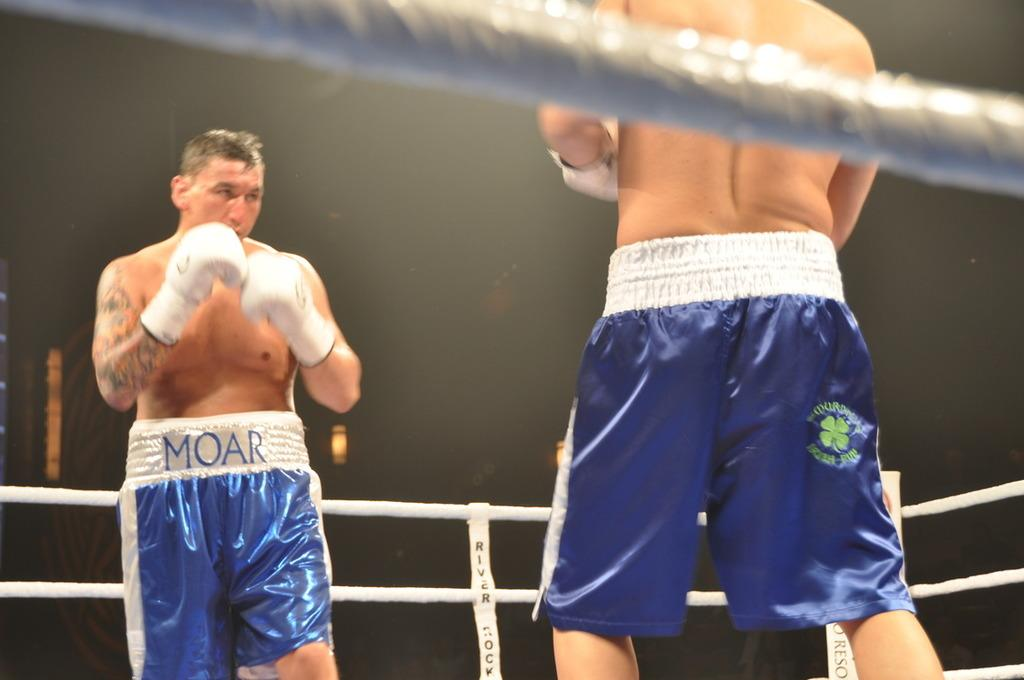<image>
Summarize the visual content of the image. Two boxers are squaring off in the ring and one of their shorts says MOAR. 